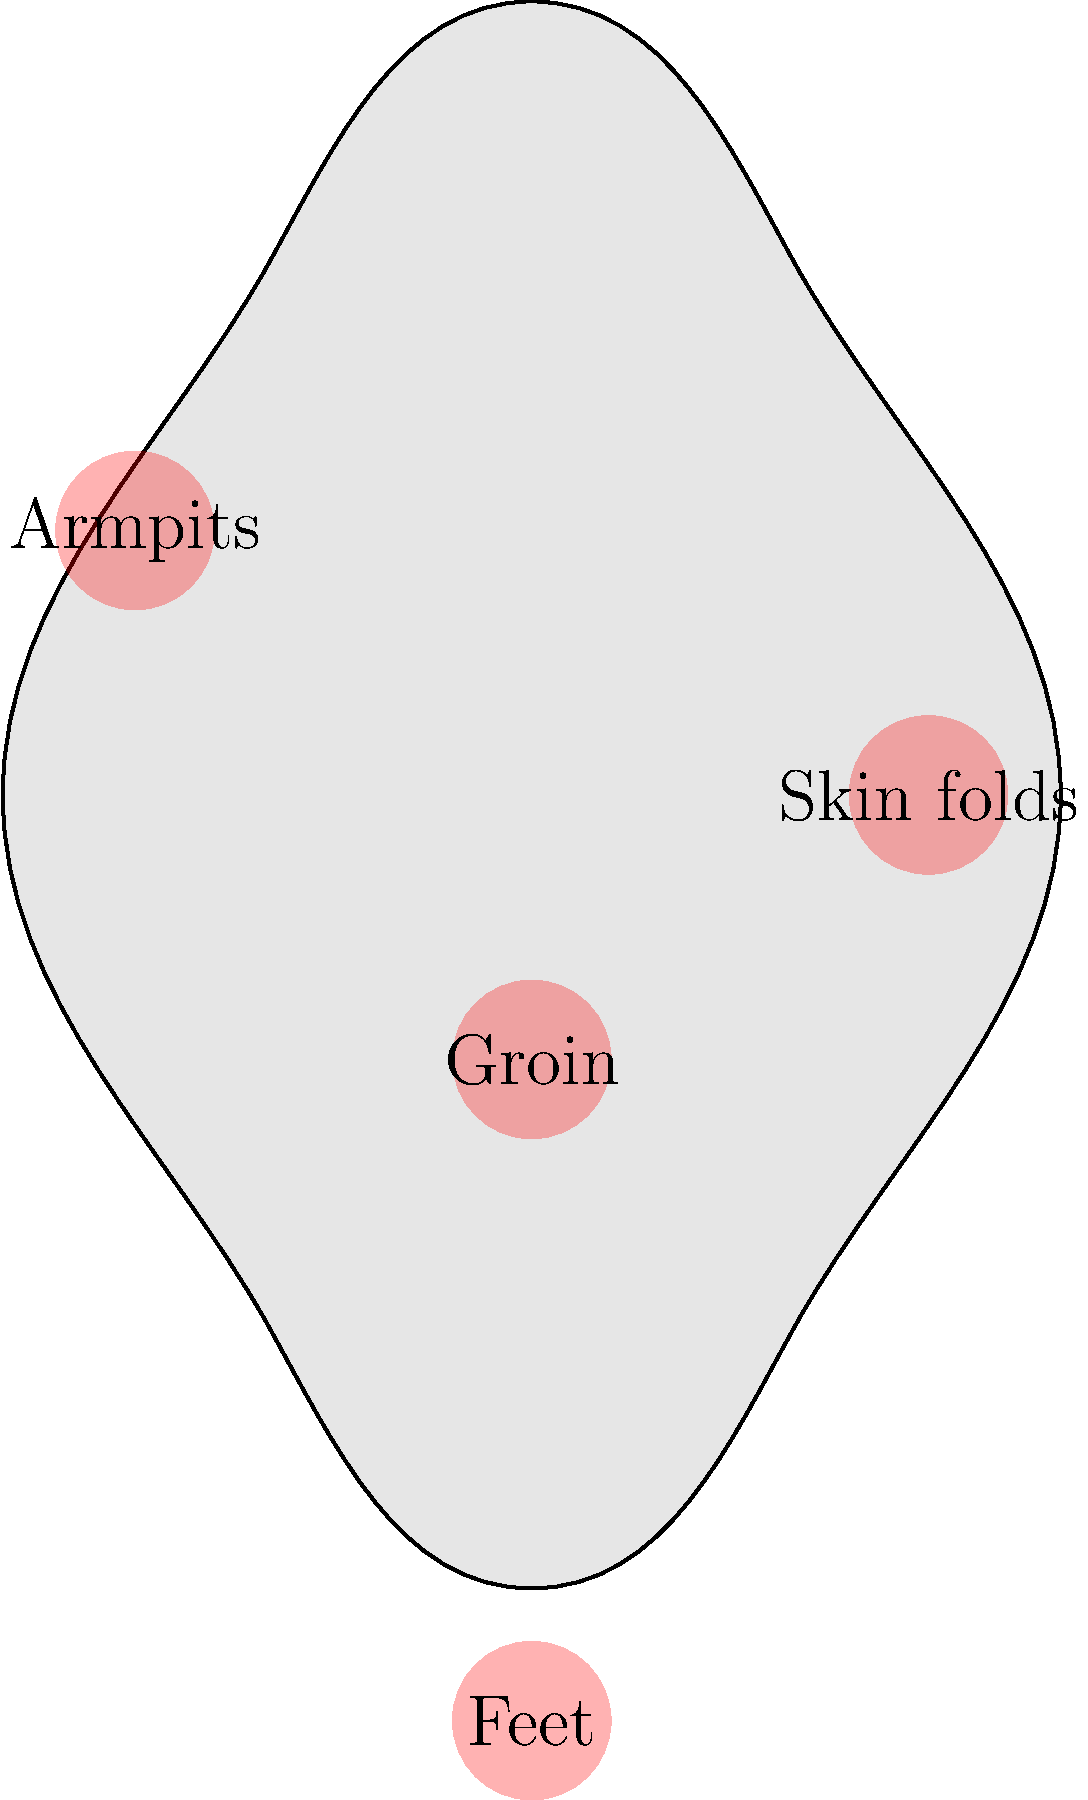Identify the anatomical regions most susceptible to fungal infections based on the highlighted areas in the human body outline provided. What common characteristic do these areas share that makes them prone to fungal growth? Step 1: Examine the highlighted areas in the body outline.
The red-highlighted areas include:
- Groin
- Feet
- Armpits
- Skin folds

Step 2: Identify the common characteristic of these areas.
These areas are all warm, moist, and often dark environments.

Step 3: Understand why these characteristics promote fungal growth.
Fungi thrive in warm, moist environments. These conditions provide the ideal setting for fungal spores to germinate and grow.

Step 4: Consider additional factors that make these areas susceptible.
- These areas often have reduced air circulation.
- They may experience friction from clothing or body movements.
- Natural skin oils and sweat can accumulate in these regions.

Step 5: Relate this information to fungal infections.
Common fungal infections like athlete's foot, jock itch, and candidiasis often occur in these areas due to the favorable conditions for fungal growth.
Answer: Warm, moist environments 